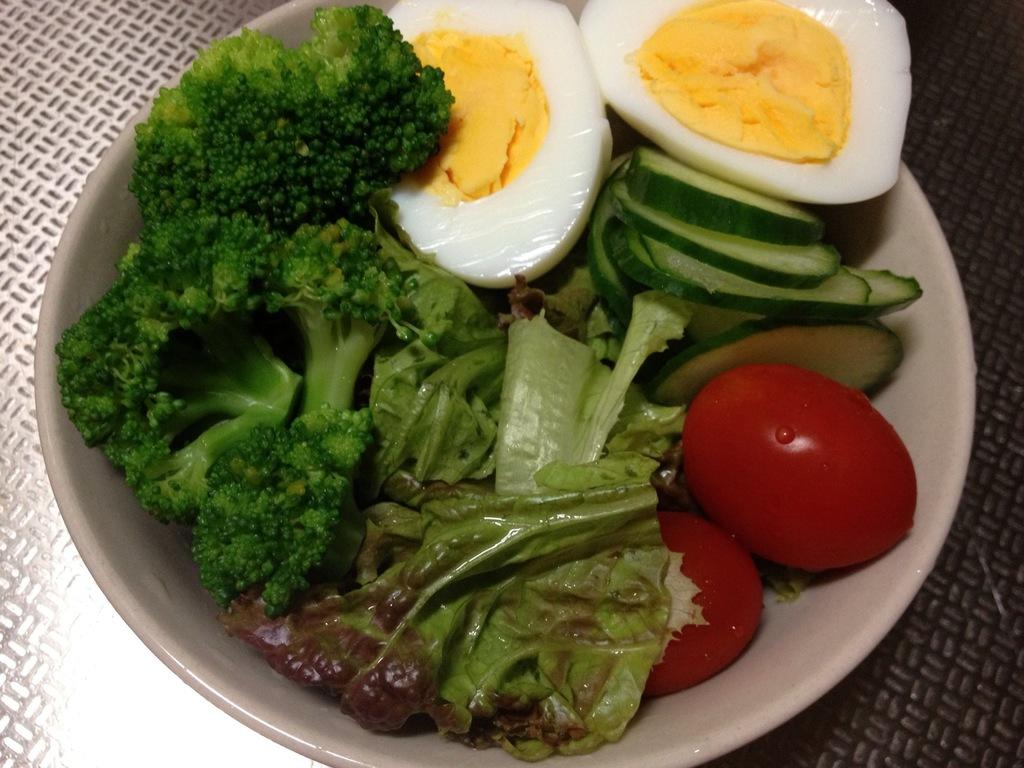What type of food items are in the bowl? There are food items in a bowl, including a piece of tomato and a piece of egg. Can you describe the location of the bowl? The bowl is kept on the floor. What type of organization is responsible for the space exploration depicted in the image? There is no depiction of space exploration in the image; it features a bowl of food items on the floor. 